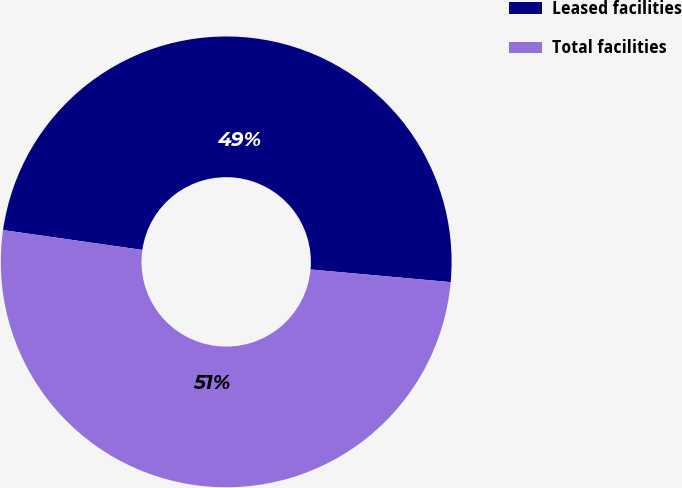Convert chart to OTSL. <chart><loc_0><loc_0><loc_500><loc_500><pie_chart><fcel>Leased facilities<fcel>Total facilities<nl><fcel>49.18%<fcel>50.82%<nl></chart> 